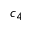Convert formula to latex. <formula><loc_0><loc_0><loc_500><loc_500>c _ { 4 }</formula> 